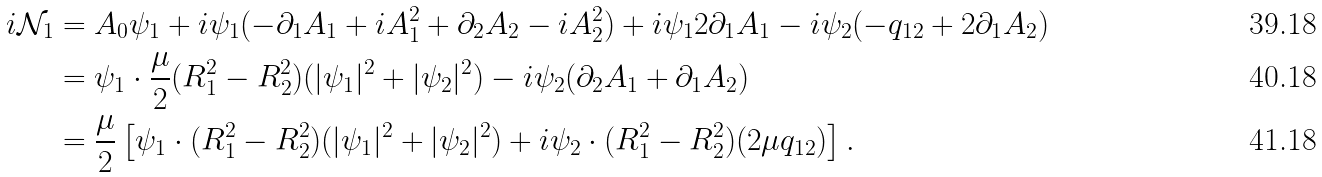Convert formula to latex. <formula><loc_0><loc_0><loc_500><loc_500>i \mathcal { N } _ { 1 } & = A _ { 0 } \psi _ { 1 } + i \psi _ { 1 } ( - \partial _ { 1 } A _ { 1 } + i A _ { 1 } ^ { 2 } + \partial _ { 2 } A _ { 2 } - i A _ { 2 } ^ { 2 } ) + i \psi _ { 1 } 2 \partial _ { 1 } A _ { 1 } - i \psi _ { 2 } ( - q _ { 1 2 } + 2 \partial _ { 1 } A _ { 2 } ) \\ & = \psi _ { 1 } \cdot \frac { \mu } { 2 } ( R _ { 1 } ^ { 2 } - R _ { 2 } ^ { 2 } ) ( | \psi _ { 1 } | ^ { 2 } + | \psi _ { 2 } | ^ { 2 } ) - i \psi _ { 2 } ( \partial _ { 2 } A _ { 1 } + \partial _ { 1 } A _ { 2 } ) \\ & = \frac { \mu } { 2 } \left [ \psi _ { 1 } \cdot ( R _ { 1 } ^ { 2 } - R _ { 2 } ^ { 2 } ) ( | \psi _ { 1 } | ^ { 2 } + | \psi _ { 2 } | ^ { 2 } ) + i \psi _ { 2 } \cdot ( R _ { 1 } ^ { 2 } - R _ { 2 } ^ { 2 } ) ( 2 \mu q _ { 1 2 } ) \right ] .</formula> 